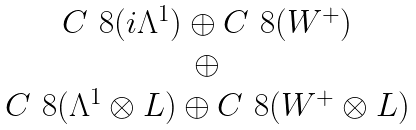Convert formula to latex. <formula><loc_0><loc_0><loc_500><loc_500>\begin{matrix} C ^ { \ } 8 ( i \Lambda ^ { 1 } ) \oplus C ^ { \ } 8 ( W ^ { + } ) \\ \oplus \\ C ^ { \ } 8 ( \Lambda ^ { 1 } \otimes L ) \oplus C ^ { \ } 8 ( W ^ { + } \otimes L ) \end{matrix}</formula> 